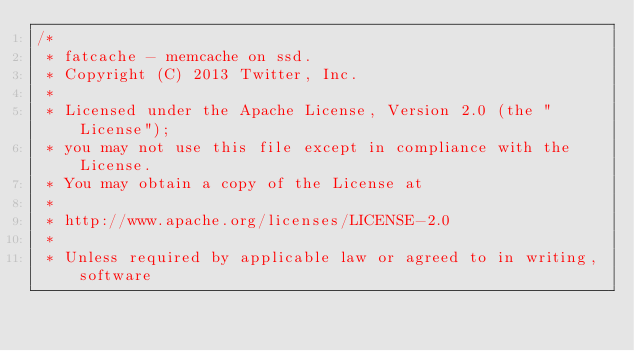Convert code to text. <code><loc_0><loc_0><loc_500><loc_500><_C_>/*
 * fatcache - memcache on ssd.
 * Copyright (C) 2013 Twitter, Inc.
 *
 * Licensed under the Apache License, Version 2.0 (the "License");
 * you may not use this file except in compliance with the License.
 * You may obtain a copy of the License at
 *
 * http://www.apache.org/licenses/LICENSE-2.0
 *
 * Unless required by applicable law or agreed to in writing, software</code> 